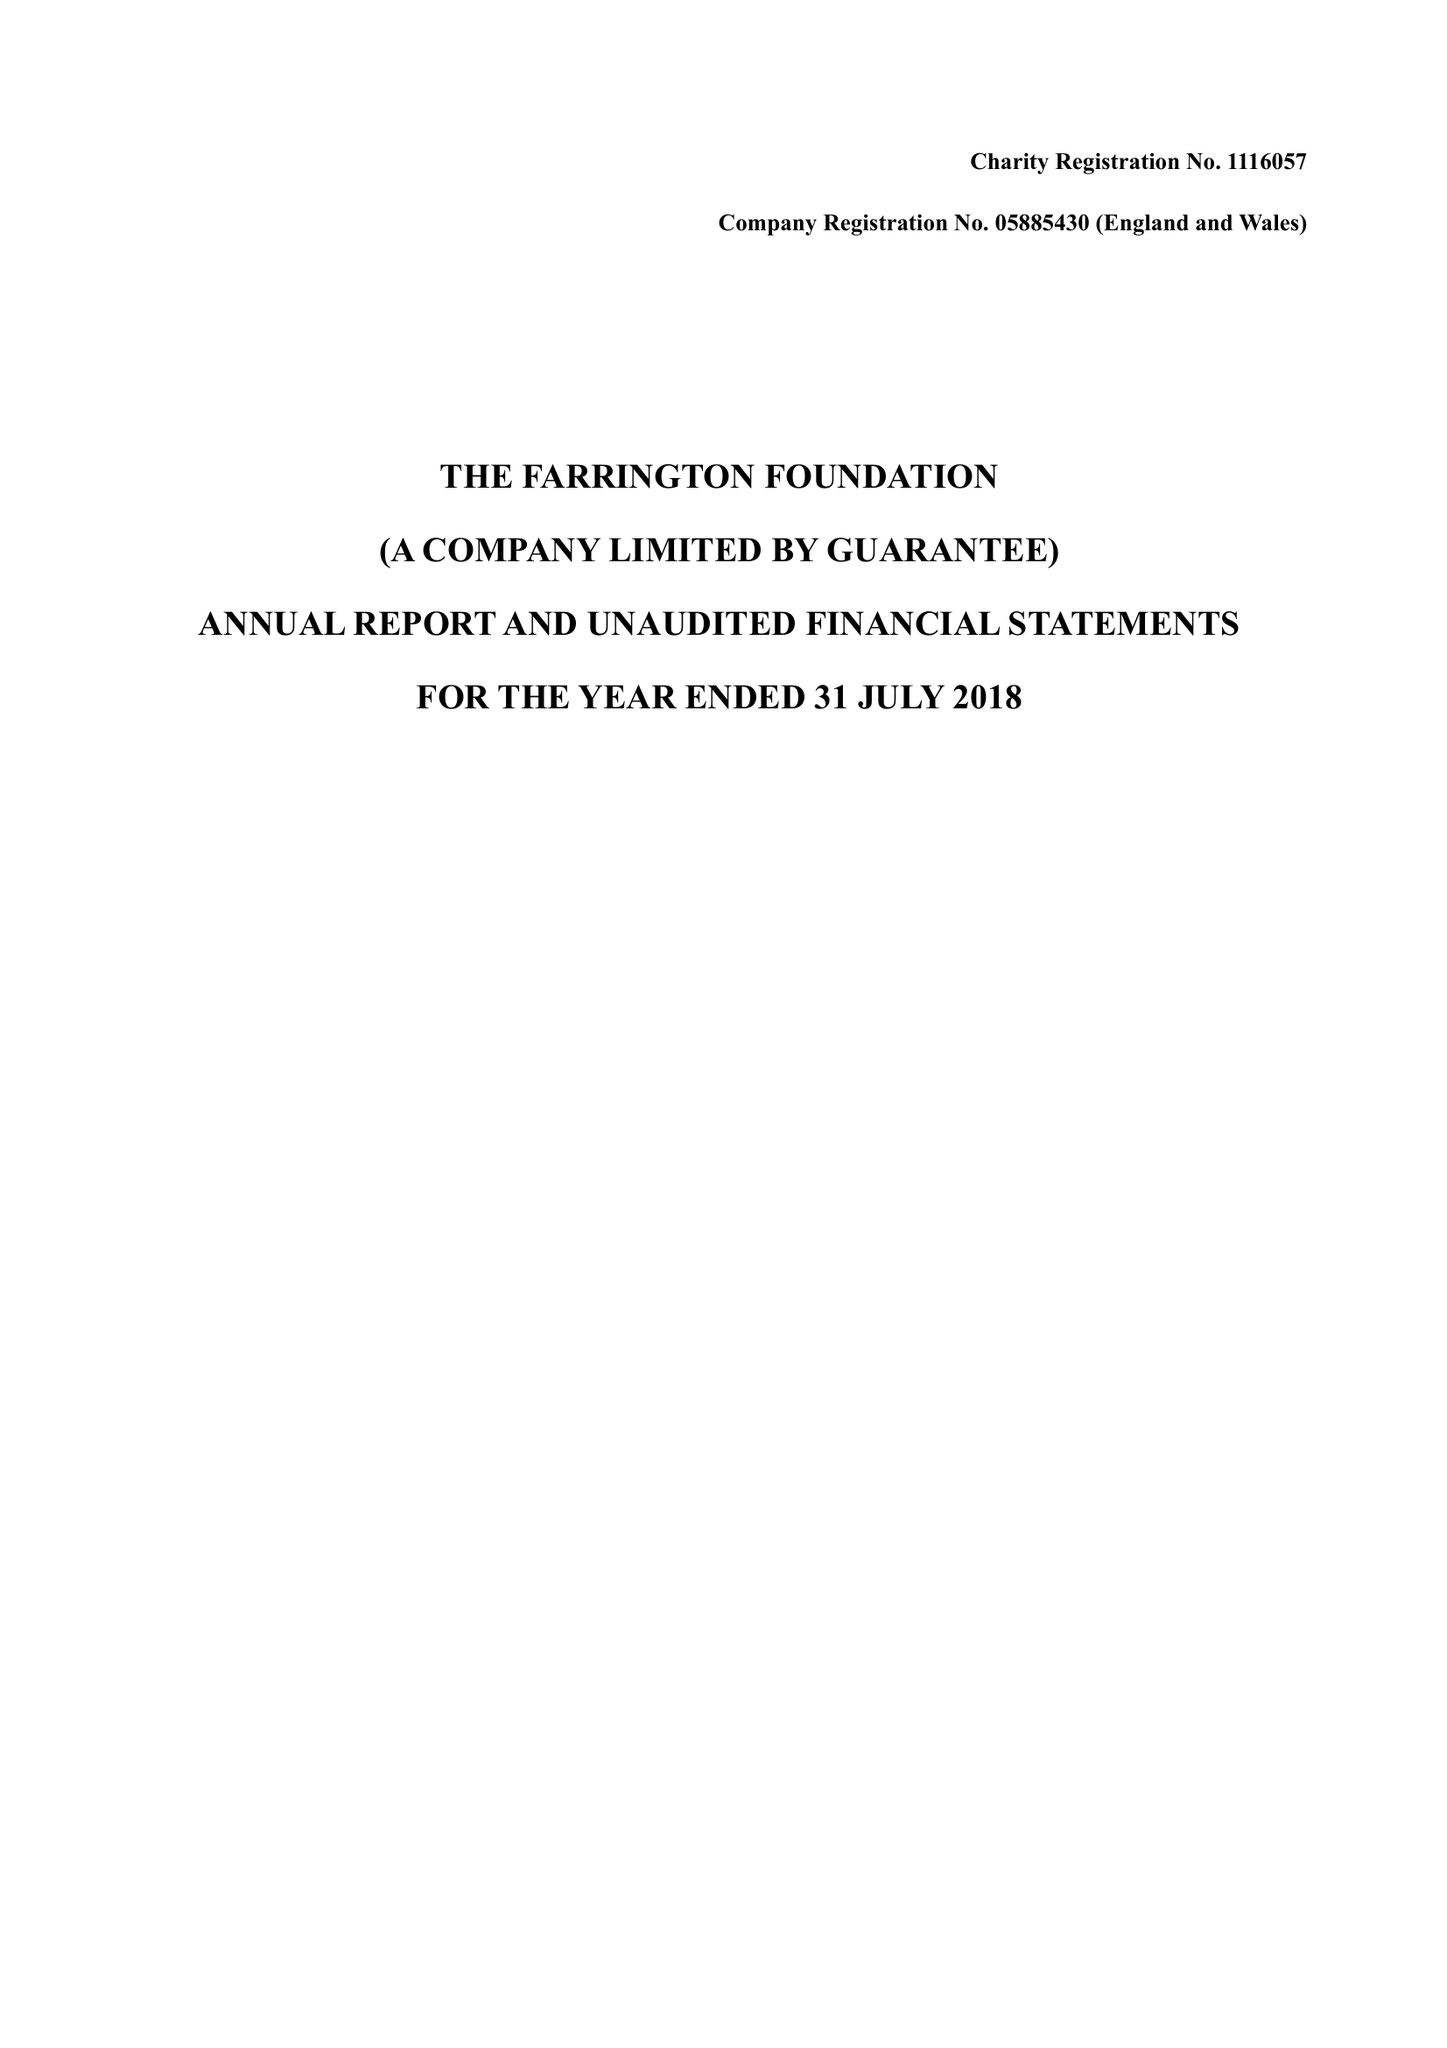What is the value for the address__post_town?
Answer the question using a single word or phrase. NORTHWOOD 